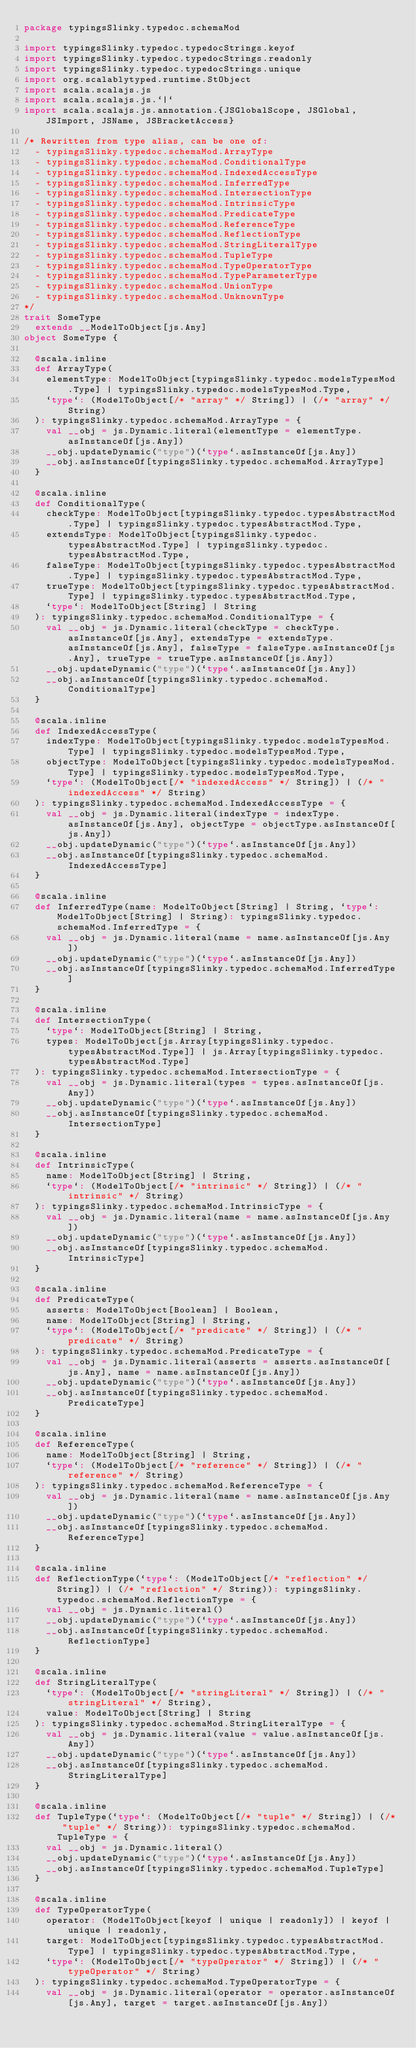Convert code to text. <code><loc_0><loc_0><loc_500><loc_500><_Scala_>package typingsSlinky.typedoc.schemaMod

import typingsSlinky.typedoc.typedocStrings.keyof
import typingsSlinky.typedoc.typedocStrings.readonly
import typingsSlinky.typedoc.typedocStrings.unique
import org.scalablytyped.runtime.StObject
import scala.scalajs.js
import scala.scalajs.js.`|`
import scala.scalajs.js.annotation.{JSGlobalScope, JSGlobal, JSImport, JSName, JSBracketAccess}

/* Rewritten from type alias, can be one of: 
  - typingsSlinky.typedoc.schemaMod.ArrayType
  - typingsSlinky.typedoc.schemaMod.ConditionalType
  - typingsSlinky.typedoc.schemaMod.IndexedAccessType
  - typingsSlinky.typedoc.schemaMod.InferredType
  - typingsSlinky.typedoc.schemaMod.IntersectionType
  - typingsSlinky.typedoc.schemaMod.IntrinsicType
  - typingsSlinky.typedoc.schemaMod.PredicateType
  - typingsSlinky.typedoc.schemaMod.ReferenceType
  - typingsSlinky.typedoc.schemaMod.ReflectionType
  - typingsSlinky.typedoc.schemaMod.StringLiteralType
  - typingsSlinky.typedoc.schemaMod.TupleType
  - typingsSlinky.typedoc.schemaMod.TypeOperatorType
  - typingsSlinky.typedoc.schemaMod.TypeParameterType
  - typingsSlinky.typedoc.schemaMod.UnionType
  - typingsSlinky.typedoc.schemaMod.UnknownType
*/
trait SomeType
  extends __ModelToObject[js.Any]
object SomeType {
  
  @scala.inline
  def ArrayType(
    elementType: ModelToObject[typingsSlinky.typedoc.modelsTypesMod.Type] | typingsSlinky.typedoc.modelsTypesMod.Type,
    `type`: (ModelToObject[/* "array" */ String]) | (/* "array" */ String)
  ): typingsSlinky.typedoc.schemaMod.ArrayType = {
    val __obj = js.Dynamic.literal(elementType = elementType.asInstanceOf[js.Any])
    __obj.updateDynamic("type")(`type`.asInstanceOf[js.Any])
    __obj.asInstanceOf[typingsSlinky.typedoc.schemaMod.ArrayType]
  }
  
  @scala.inline
  def ConditionalType(
    checkType: ModelToObject[typingsSlinky.typedoc.typesAbstractMod.Type] | typingsSlinky.typedoc.typesAbstractMod.Type,
    extendsType: ModelToObject[typingsSlinky.typedoc.typesAbstractMod.Type] | typingsSlinky.typedoc.typesAbstractMod.Type,
    falseType: ModelToObject[typingsSlinky.typedoc.typesAbstractMod.Type] | typingsSlinky.typedoc.typesAbstractMod.Type,
    trueType: ModelToObject[typingsSlinky.typedoc.typesAbstractMod.Type] | typingsSlinky.typedoc.typesAbstractMod.Type,
    `type`: ModelToObject[String] | String
  ): typingsSlinky.typedoc.schemaMod.ConditionalType = {
    val __obj = js.Dynamic.literal(checkType = checkType.asInstanceOf[js.Any], extendsType = extendsType.asInstanceOf[js.Any], falseType = falseType.asInstanceOf[js.Any], trueType = trueType.asInstanceOf[js.Any])
    __obj.updateDynamic("type")(`type`.asInstanceOf[js.Any])
    __obj.asInstanceOf[typingsSlinky.typedoc.schemaMod.ConditionalType]
  }
  
  @scala.inline
  def IndexedAccessType(
    indexType: ModelToObject[typingsSlinky.typedoc.modelsTypesMod.Type] | typingsSlinky.typedoc.modelsTypesMod.Type,
    objectType: ModelToObject[typingsSlinky.typedoc.modelsTypesMod.Type] | typingsSlinky.typedoc.modelsTypesMod.Type,
    `type`: (ModelToObject[/* "indexedAccess" */ String]) | (/* "indexedAccess" */ String)
  ): typingsSlinky.typedoc.schemaMod.IndexedAccessType = {
    val __obj = js.Dynamic.literal(indexType = indexType.asInstanceOf[js.Any], objectType = objectType.asInstanceOf[js.Any])
    __obj.updateDynamic("type")(`type`.asInstanceOf[js.Any])
    __obj.asInstanceOf[typingsSlinky.typedoc.schemaMod.IndexedAccessType]
  }
  
  @scala.inline
  def InferredType(name: ModelToObject[String] | String, `type`: ModelToObject[String] | String): typingsSlinky.typedoc.schemaMod.InferredType = {
    val __obj = js.Dynamic.literal(name = name.asInstanceOf[js.Any])
    __obj.updateDynamic("type")(`type`.asInstanceOf[js.Any])
    __obj.asInstanceOf[typingsSlinky.typedoc.schemaMod.InferredType]
  }
  
  @scala.inline
  def IntersectionType(
    `type`: ModelToObject[String] | String,
    types: ModelToObject[js.Array[typingsSlinky.typedoc.typesAbstractMod.Type]] | js.Array[typingsSlinky.typedoc.typesAbstractMod.Type]
  ): typingsSlinky.typedoc.schemaMod.IntersectionType = {
    val __obj = js.Dynamic.literal(types = types.asInstanceOf[js.Any])
    __obj.updateDynamic("type")(`type`.asInstanceOf[js.Any])
    __obj.asInstanceOf[typingsSlinky.typedoc.schemaMod.IntersectionType]
  }
  
  @scala.inline
  def IntrinsicType(
    name: ModelToObject[String] | String,
    `type`: (ModelToObject[/* "intrinsic" */ String]) | (/* "intrinsic" */ String)
  ): typingsSlinky.typedoc.schemaMod.IntrinsicType = {
    val __obj = js.Dynamic.literal(name = name.asInstanceOf[js.Any])
    __obj.updateDynamic("type")(`type`.asInstanceOf[js.Any])
    __obj.asInstanceOf[typingsSlinky.typedoc.schemaMod.IntrinsicType]
  }
  
  @scala.inline
  def PredicateType(
    asserts: ModelToObject[Boolean] | Boolean,
    name: ModelToObject[String] | String,
    `type`: (ModelToObject[/* "predicate" */ String]) | (/* "predicate" */ String)
  ): typingsSlinky.typedoc.schemaMod.PredicateType = {
    val __obj = js.Dynamic.literal(asserts = asserts.asInstanceOf[js.Any], name = name.asInstanceOf[js.Any])
    __obj.updateDynamic("type")(`type`.asInstanceOf[js.Any])
    __obj.asInstanceOf[typingsSlinky.typedoc.schemaMod.PredicateType]
  }
  
  @scala.inline
  def ReferenceType(
    name: ModelToObject[String] | String,
    `type`: (ModelToObject[/* "reference" */ String]) | (/* "reference" */ String)
  ): typingsSlinky.typedoc.schemaMod.ReferenceType = {
    val __obj = js.Dynamic.literal(name = name.asInstanceOf[js.Any])
    __obj.updateDynamic("type")(`type`.asInstanceOf[js.Any])
    __obj.asInstanceOf[typingsSlinky.typedoc.schemaMod.ReferenceType]
  }
  
  @scala.inline
  def ReflectionType(`type`: (ModelToObject[/* "reflection" */ String]) | (/* "reflection" */ String)): typingsSlinky.typedoc.schemaMod.ReflectionType = {
    val __obj = js.Dynamic.literal()
    __obj.updateDynamic("type")(`type`.asInstanceOf[js.Any])
    __obj.asInstanceOf[typingsSlinky.typedoc.schemaMod.ReflectionType]
  }
  
  @scala.inline
  def StringLiteralType(
    `type`: (ModelToObject[/* "stringLiteral" */ String]) | (/* "stringLiteral" */ String),
    value: ModelToObject[String] | String
  ): typingsSlinky.typedoc.schemaMod.StringLiteralType = {
    val __obj = js.Dynamic.literal(value = value.asInstanceOf[js.Any])
    __obj.updateDynamic("type")(`type`.asInstanceOf[js.Any])
    __obj.asInstanceOf[typingsSlinky.typedoc.schemaMod.StringLiteralType]
  }
  
  @scala.inline
  def TupleType(`type`: (ModelToObject[/* "tuple" */ String]) | (/* "tuple" */ String)): typingsSlinky.typedoc.schemaMod.TupleType = {
    val __obj = js.Dynamic.literal()
    __obj.updateDynamic("type")(`type`.asInstanceOf[js.Any])
    __obj.asInstanceOf[typingsSlinky.typedoc.schemaMod.TupleType]
  }
  
  @scala.inline
  def TypeOperatorType(
    operator: (ModelToObject[keyof | unique | readonly]) | keyof | unique | readonly,
    target: ModelToObject[typingsSlinky.typedoc.typesAbstractMod.Type] | typingsSlinky.typedoc.typesAbstractMod.Type,
    `type`: (ModelToObject[/* "typeOperator" */ String]) | (/* "typeOperator" */ String)
  ): typingsSlinky.typedoc.schemaMod.TypeOperatorType = {
    val __obj = js.Dynamic.literal(operator = operator.asInstanceOf[js.Any], target = target.asInstanceOf[js.Any])</code> 